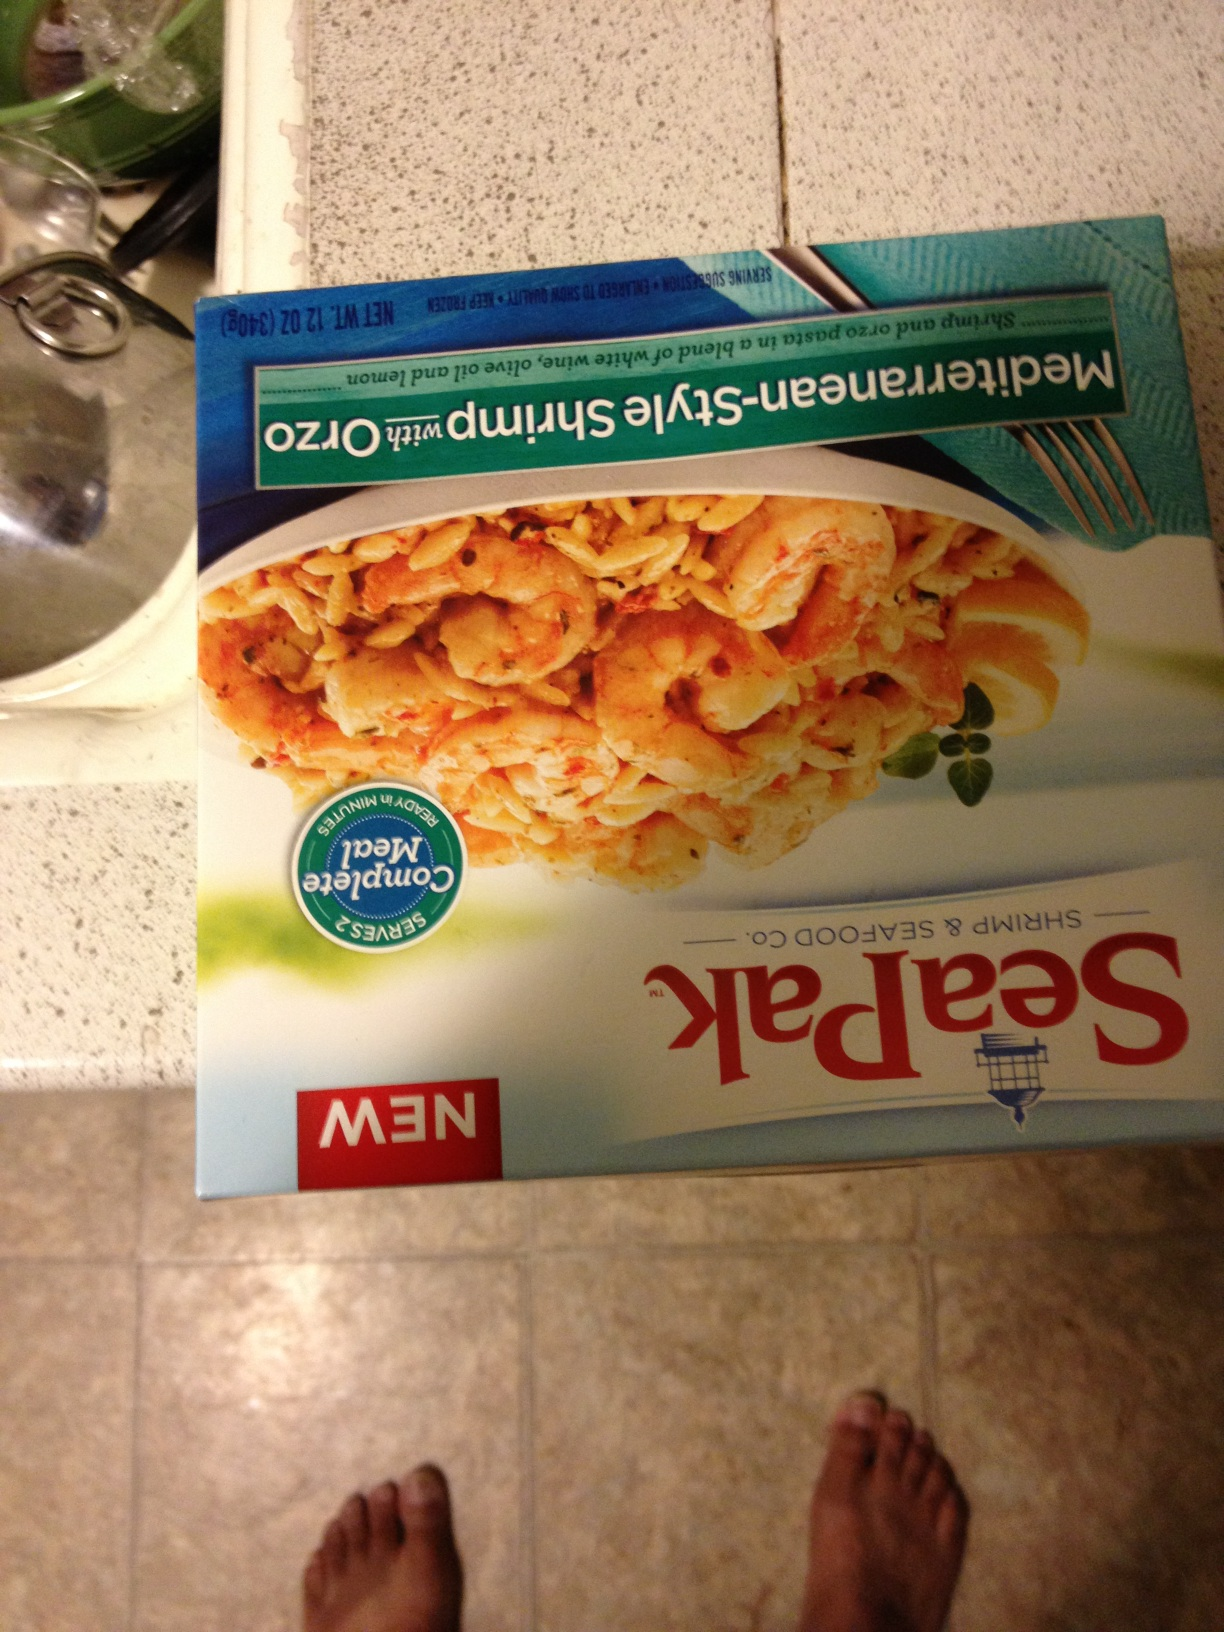What is this? This is a package of Seapak's Mediterranean-inspired Shrimp Scampi. It's a frozen seafood product that includes shrimp seasoned with a blend of Mediterranean herbs and spices. 